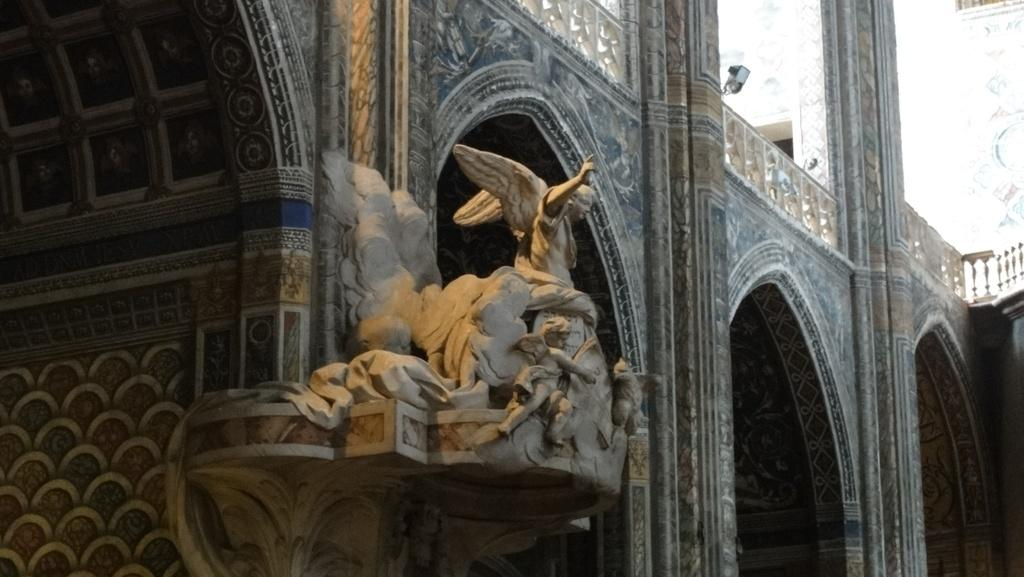What is the main subject of the image? The main subject of the image is a building. Are there any additional features or objects in the image? Yes, there is a sculpture in the image. How are the walls of the building decorated? The walls of the building are decorated. Can you identify any other objects in the image? There is an object that resembles a camera in the image. What type of flowers are growing in the recess of the building in the image? There are no flowers visible in the image, nor is there a recess in the building. 